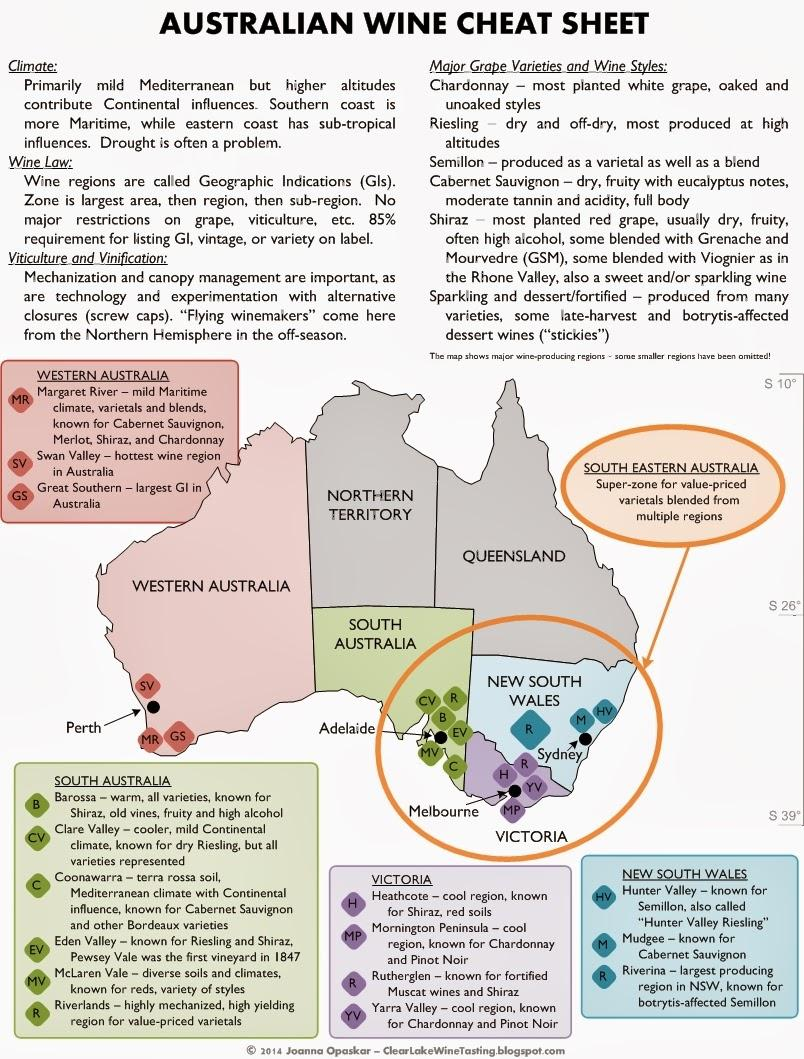Mention a couple of crucial points in this snapshot. The Riverina region is renowned for producing botrytis-affected Semillon wines, known for their unique aroma and flavor profile. Great Southern is the largest geographic indication in Australia. Shiraz wine, known for its high alcohol content, is a popular choice among wine drinkers. South Australia in the map is primarily colored green, with possible variations of blue or grey. The color may vary depending on the map and its purpose, but it is generally acknowledged to be predominantly green. The region with red soil is Heathcote. 